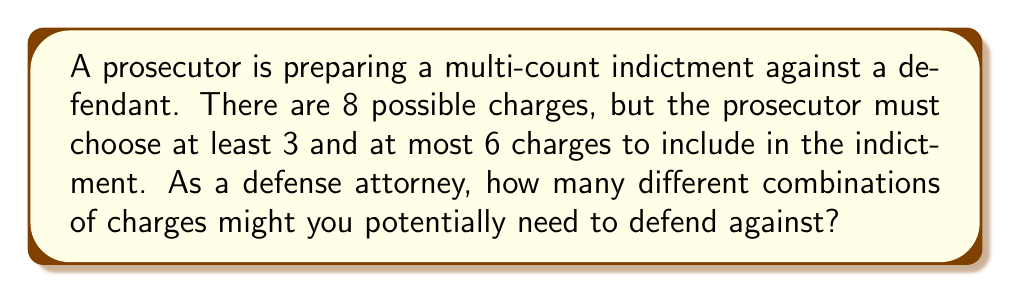Solve this math problem. Let's approach this step-by-step:

1) We need to calculate the sum of combinations for selecting 3, 4, 5, and 6 charges out of 8 possible charges.

2) The formula for combinations is:

   $${n \choose k} = \frac{n!}{k!(n-k)!}$$

   where $n$ is the total number of items and $k$ is the number of items being chosen.

3) Let's calculate each combination:

   For 3 charges: $${8 \choose 3} = \frac{8!}{3!(8-3)!} = \frac{8!}{3!5!} = 56$$

   For 4 charges: $${8 \choose 4} = \frac{8!}{4!(8-4)!} = \frac{8!}{4!4!} = 70$$

   For 5 charges: $${8 \choose 5} = \frac{8!}{5!(8-5)!} = \frac{8!}{5!3!} = 56$$

   For 6 charges: $${8 \choose 6} = \frac{8!}{6!(8-6)!} = \frac{8!}{6!2!} = 28$$

4) The total number of possible combinations is the sum of these:

   $$56 + 70 + 56 + 28 = 210$$

Therefore, as a defense attorney, you might need to be prepared to defend against 210 different combinations of charges.
Answer: 210 combinations 